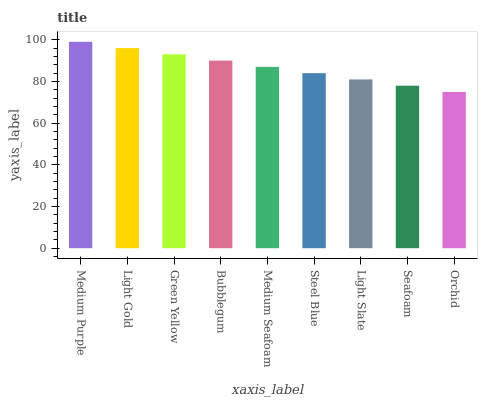Is Orchid the minimum?
Answer yes or no. Yes. Is Medium Purple the maximum?
Answer yes or no. Yes. Is Light Gold the minimum?
Answer yes or no. No. Is Light Gold the maximum?
Answer yes or no. No. Is Medium Purple greater than Light Gold?
Answer yes or no. Yes. Is Light Gold less than Medium Purple?
Answer yes or no. Yes. Is Light Gold greater than Medium Purple?
Answer yes or no. No. Is Medium Purple less than Light Gold?
Answer yes or no. No. Is Medium Seafoam the high median?
Answer yes or no. Yes. Is Medium Seafoam the low median?
Answer yes or no. Yes. Is Green Yellow the high median?
Answer yes or no. No. Is Orchid the low median?
Answer yes or no. No. 